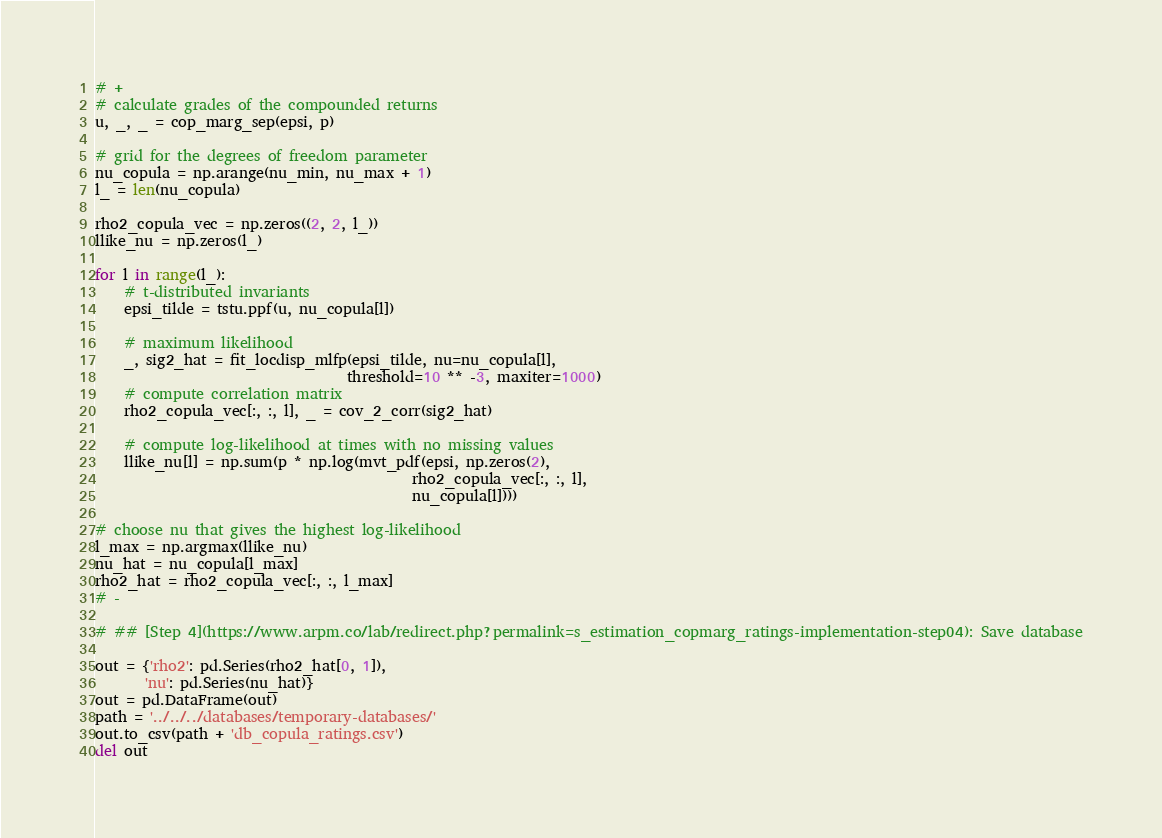Convert code to text. <code><loc_0><loc_0><loc_500><loc_500><_Python_>
# +
# calculate grades of the compounded returns
u, _, _ = cop_marg_sep(epsi, p)

# grid for the degrees of freedom parameter
nu_copula = np.arange(nu_min, nu_max + 1)
l_ = len(nu_copula)

rho2_copula_vec = np.zeros((2, 2, l_))
llike_nu = np.zeros(l_)

for l in range(l_):
    # t-distributed invariants
    epsi_tilde = tstu.ppf(u, nu_copula[l])

    # maximum likelihood
    _, sig2_hat = fit_locdisp_mlfp(epsi_tilde, nu=nu_copula[l],
                                   threshold=10 ** -3, maxiter=1000)
    # compute correlation matrix
    rho2_copula_vec[:, :, l], _ = cov_2_corr(sig2_hat)

    # compute log-likelihood at times with no missing values
    llike_nu[l] = np.sum(p * np.log(mvt_pdf(epsi, np.zeros(2),
                                            rho2_copula_vec[:, :, l],
                                            nu_copula[l])))

# choose nu that gives the highest log-likelihood
l_max = np.argmax(llike_nu)
nu_hat = nu_copula[l_max]
rho2_hat = rho2_copula_vec[:, :, l_max]
# -

# ## [Step 4](https://www.arpm.co/lab/redirect.php?permalink=s_estimation_copmarg_ratings-implementation-step04): Save database

out = {'rho2': pd.Series(rho2_hat[0, 1]),
       'nu': pd.Series(nu_hat)}
out = pd.DataFrame(out)
path = '../../../databases/temporary-databases/'
out.to_csv(path + 'db_copula_ratings.csv')
del out
</code> 